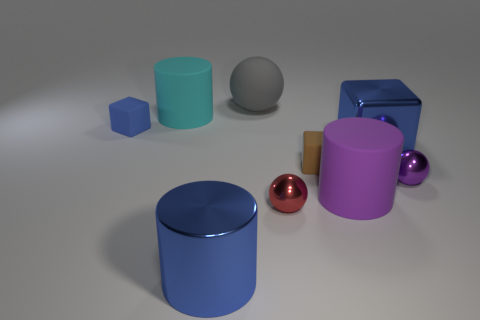Is the color of the large metal block the same as the shiny cylinder?
Provide a short and direct response. Yes. Are there more large shiny cylinders behind the tiny brown object than brown metal cylinders?
Give a very brief answer. No. What is the shape of the red thing that is made of the same material as the big blue cylinder?
Offer a terse response. Sphere. Is the size of the cylinder that is right of the gray ball the same as the blue rubber object?
Provide a succinct answer. No. There is a blue object on the right side of the large blue metallic object in front of the red ball; what is its shape?
Make the answer very short. Cube. There is a blue metallic object in front of the rubber cube that is in front of the small blue rubber thing; what size is it?
Give a very brief answer. Large. What is the color of the large metal object that is in front of the small purple ball?
Offer a very short reply. Blue. There is a brown thing that is the same material as the gray sphere; what is its size?
Make the answer very short. Small. How many small brown matte objects have the same shape as the tiny red thing?
Offer a very short reply. 0. There is a gray thing that is the same size as the blue metallic cube; what material is it?
Your answer should be compact. Rubber. 